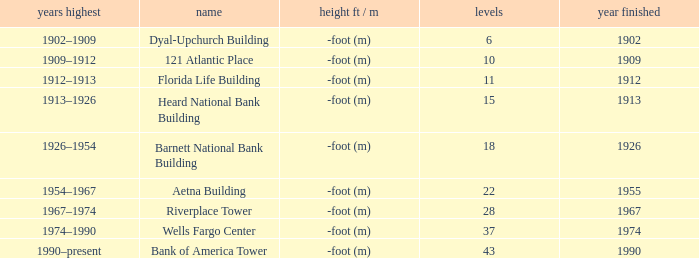What was the name of the building with 10 floors? 121 Atlantic Place. 